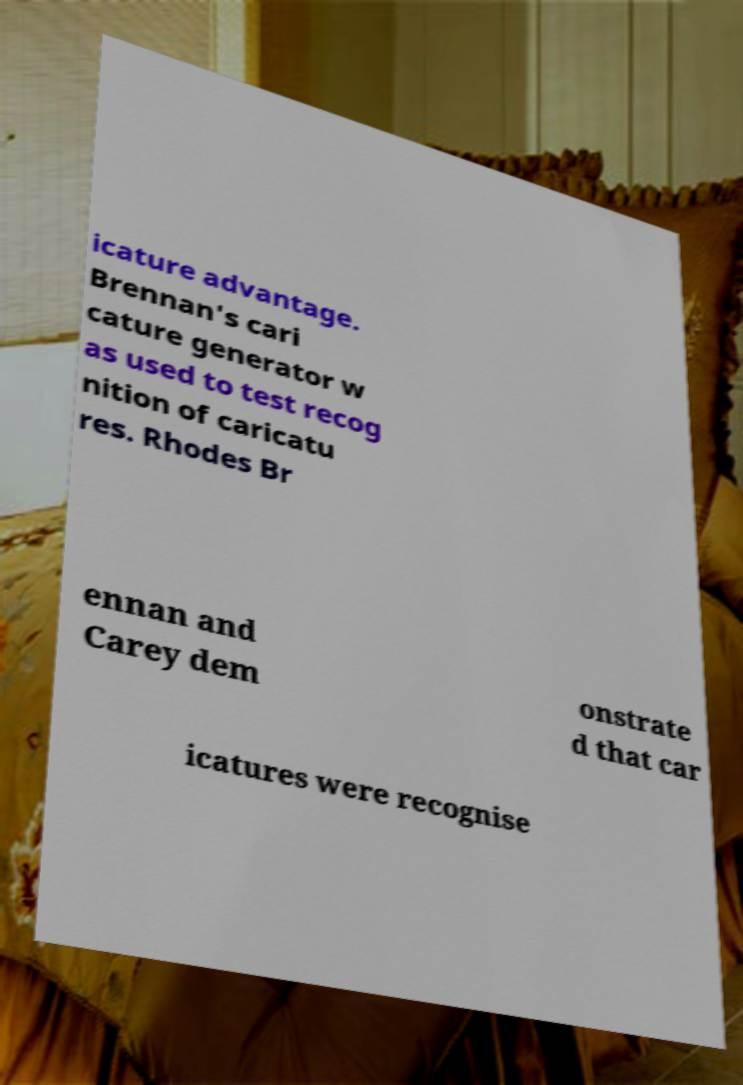Please identify and transcribe the text found in this image. icature advantage. Brennan's cari cature generator w as used to test recog nition of caricatu res. Rhodes Br ennan and Carey dem onstrate d that car icatures were recognise 